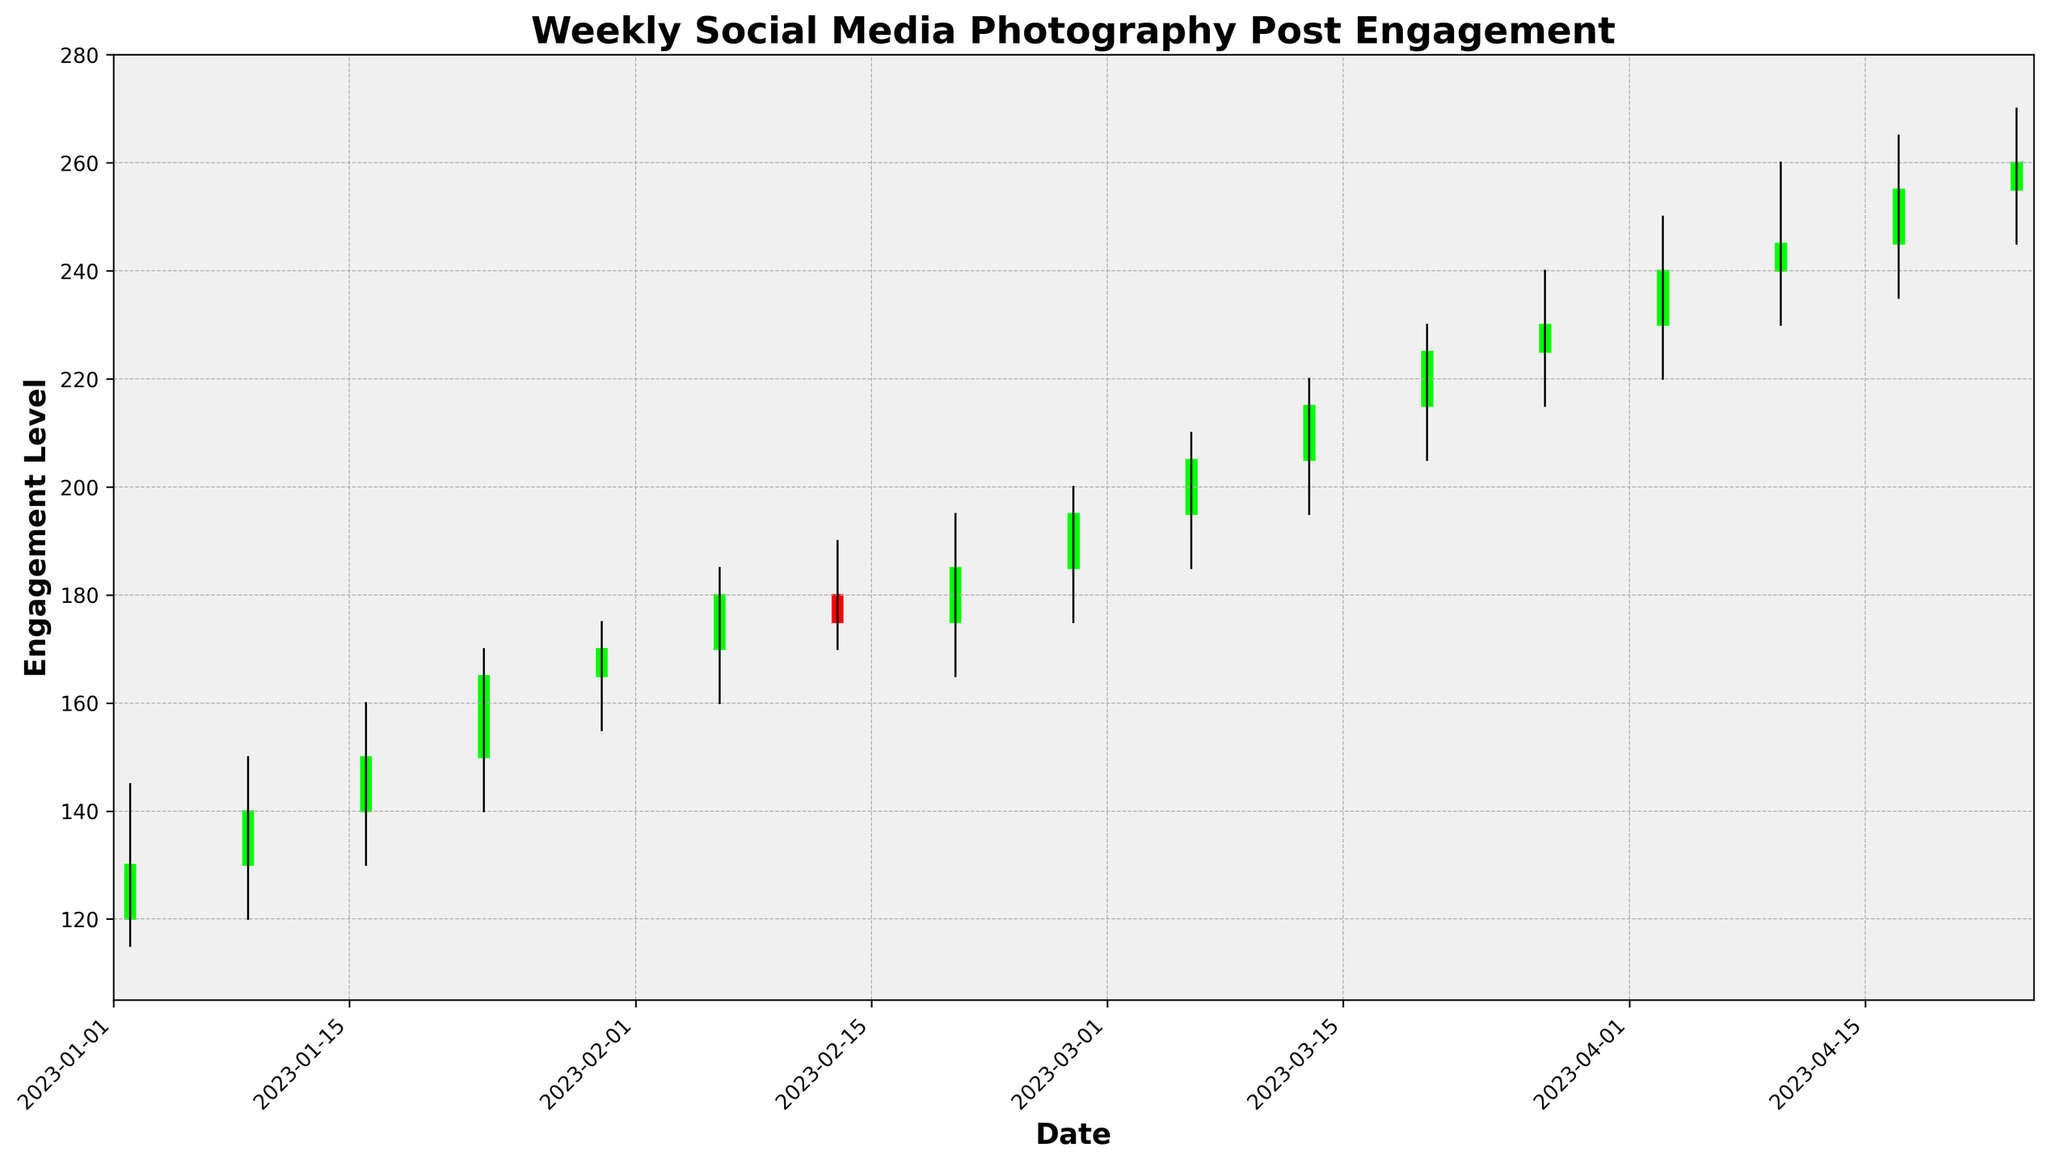What was the highest weekly engagement level across the period? Scan the figure for the tallest candlestick, which represents the week with the highest engagement. The highest point reached is 260.
Answer: 260 How many weeks have engagement levels closing higher than they opened? Look for green candlesticks, as these indicate weeks where the close value is higher than the open value. Count the green candlesticks. There are 12 green candlesticks.
Answer: 12 Which week had the smallest range between the highest engagement and the lowest engagement? Identify the shortest high-low lines on the candlesticks. The week of 2023-04-03 has the shortest range, from 220 to 250, a range of 30 units.
Answer: 2023-04-03 Between the weeks of 2023-02-13 and 2023-02-20, which one had a higher closing engagement level? Compare the closing values for the weeks of 2023-02-13 (175) and 2023-02-20 (185). The week of 2023-02-20 has a higher closing value.
Answer: 2023-02-20 What was the change in engagement level from the open of the first week to the close of the last week? Find the open value of the first week (120) and the close value of the last week (260). The change is 260 - 120 = 140 units.
Answer: 140 Which weeks had a decrease in engagement levels from open to close? Look for red candlesticks, which indicate weeks where the close value is lower than the open value. The weeks are 2023-02-13 and 2023-04-17.
Answer: 2023-02-13, 2023-04-17 During which week was the increase in engagement level the largest from open to close? Calculate the difference between the open and close values for each week and identify the largest increase. The week of 2023-04-10 had an increase from 240 to 245, a difference of 5 units.
Answer: 2023-04-10 What is the longest high-low line on the candlestick chart? Identify the longest high-low line by comparing the distances between high and low values. The longest line is on the week of 2023-04-10 with a range from 230 to 260, a difference of 30 units.
Answer: 2023-04-10 Between which two consecutive weeks was there the largest drop in closing engagement levels? Subtract the closing values of consecutive weeks and identify the largest negative difference. The largest drop is between 2023-02-13 (175) and 2023-02-20 (185), a drop of 10 units.
Answer: 2023-02-13 and 2023-02-20 